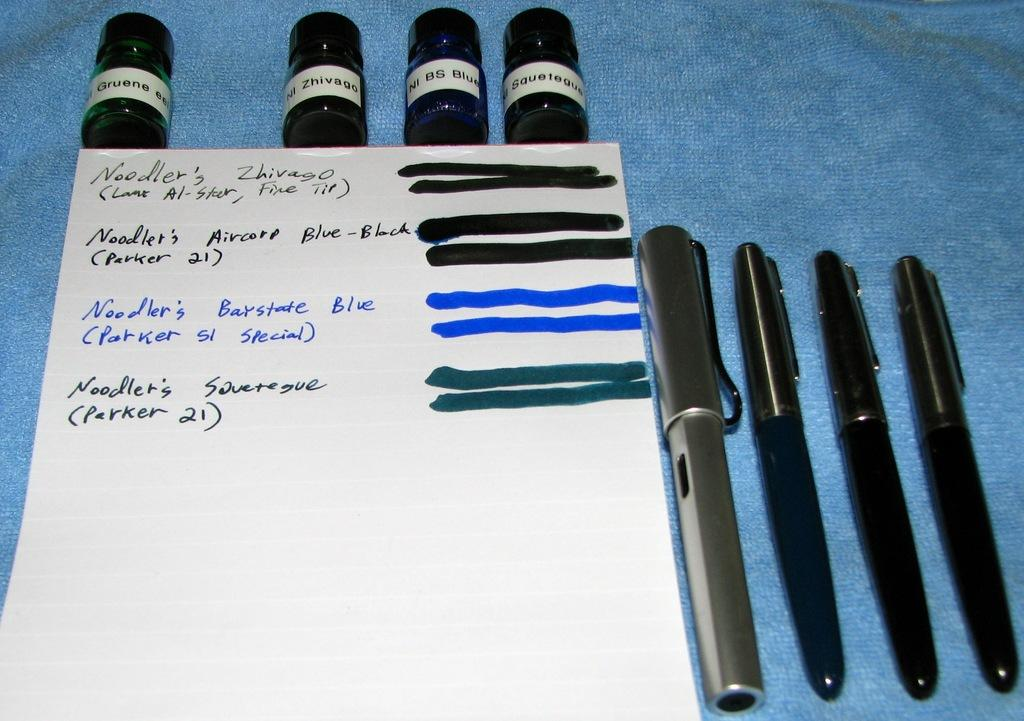What type of writing instruments are in the image? There are pens in the image. What colors are the pens? The pens are black and grey in color. What is the paper with writing on it used for? The paper with writing on it is likely used for taking notes or writing. What else can be seen in the image besides pens and paper? There are bottles in the image. What is the color of the surface the items are on? The surface the items are on is blue. How many cherries are on the stove in the image? There are no cherries or stoves present in the image. 